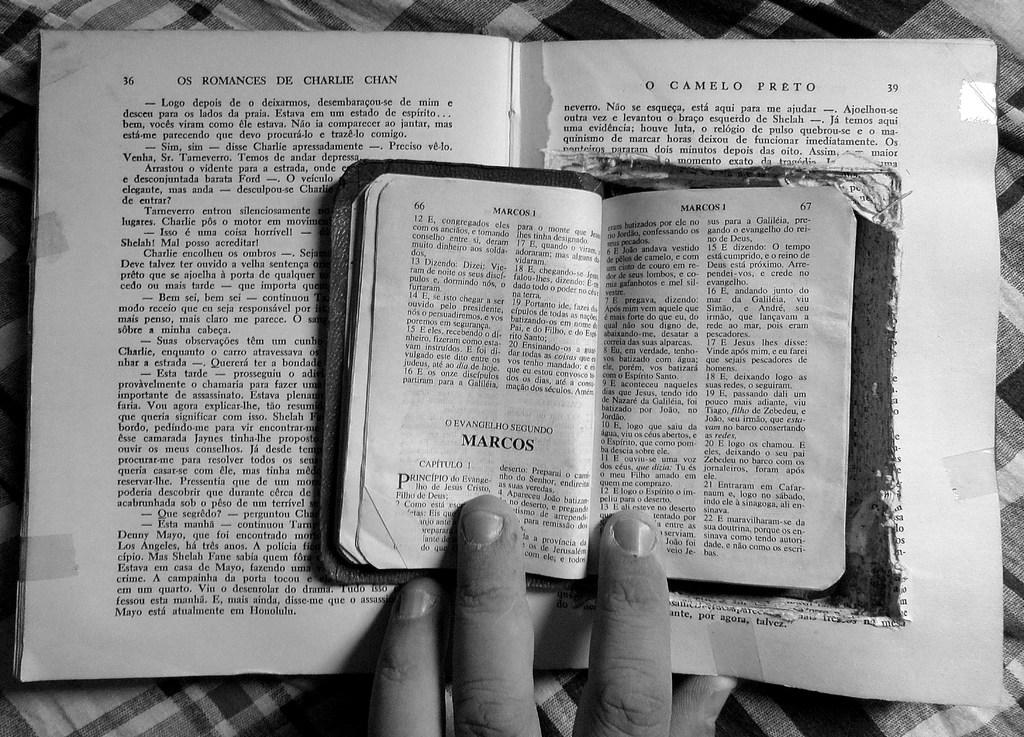<image>
Render a clear and concise summary of the photo. A black and white image of an open book with the chapter titled MARCOS 